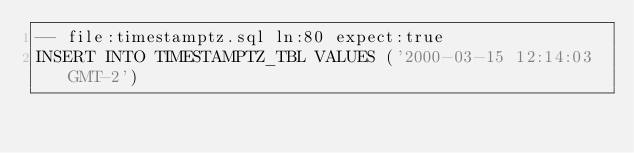<code> <loc_0><loc_0><loc_500><loc_500><_SQL_>-- file:timestamptz.sql ln:80 expect:true
INSERT INTO TIMESTAMPTZ_TBL VALUES ('2000-03-15 12:14:03 GMT-2')
</code> 